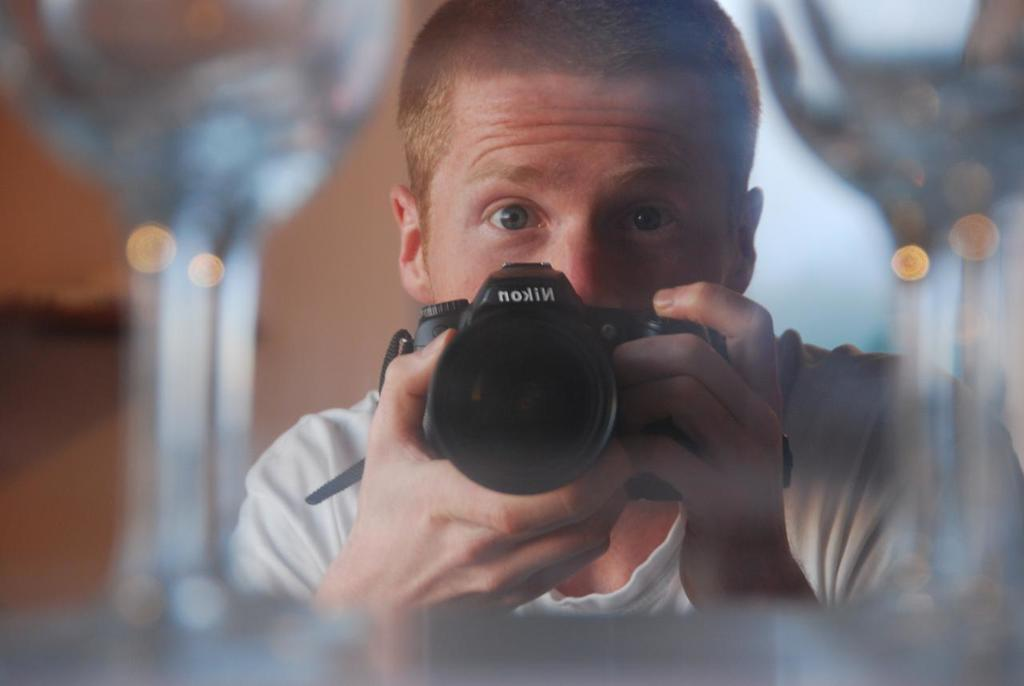Who is the main subject in the image? There is a man in the image. What is the man doing in the image? The man is holding a camera and taking a picture. Can you describe any other objects in the image? There are glasses visible in the image. How many cakes are on the table in the image? There are no cakes visible in the image. 